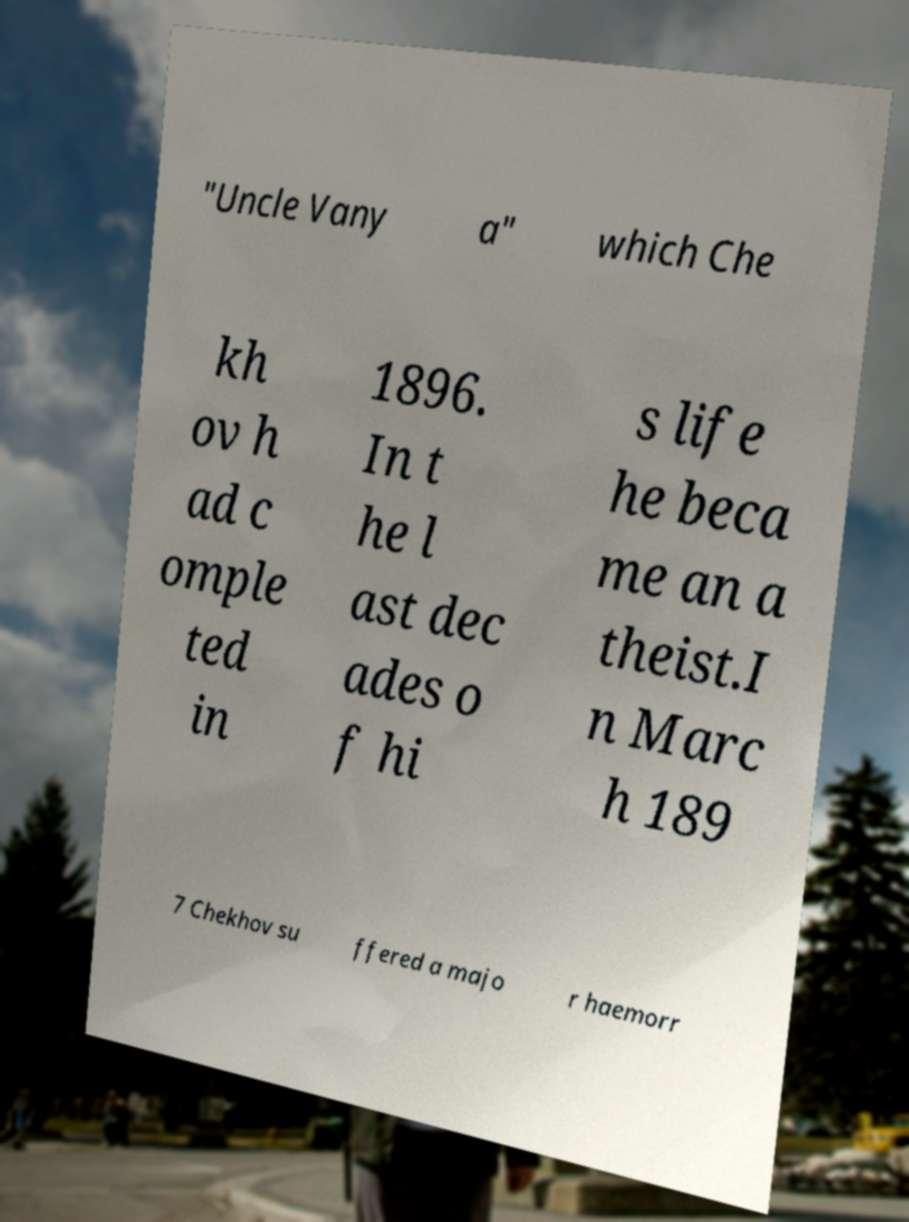What messages or text are displayed in this image? I need them in a readable, typed format. "Uncle Vany a" which Che kh ov h ad c omple ted in 1896. In t he l ast dec ades o f hi s life he beca me an a theist.I n Marc h 189 7 Chekhov su ffered a majo r haemorr 